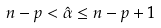<formula> <loc_0><loc_0><loc_500><loc_500>n - p < \hat { \alpha } \leq n - p + 1</formula> 